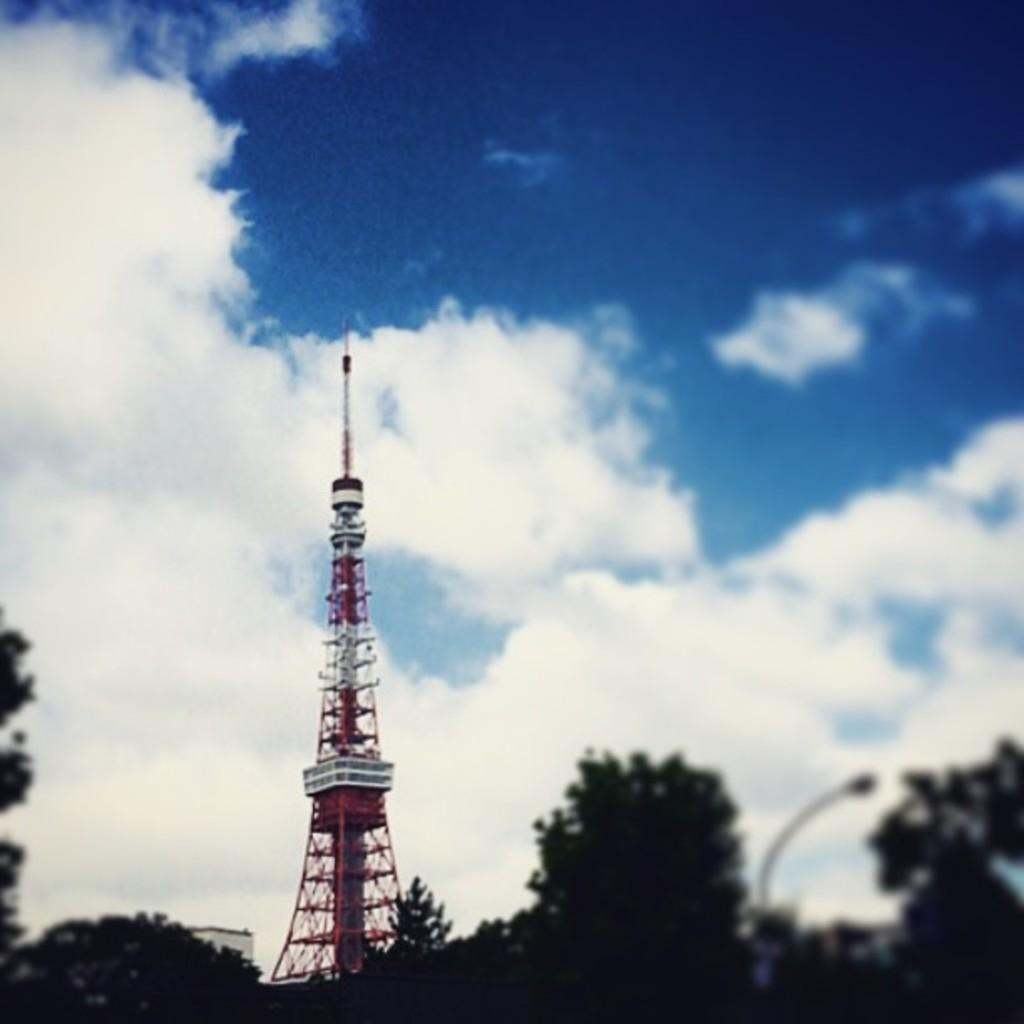What is the main structure in the image? There is a tower in the image. What can be seen in the background of the image? The sky is visible in the background of the image. What is the condition of the sky in the image? Clouds are present in the sky. What direction is the zebra facing in the image? There is no zebra present in the image, so it is not possible to determine the direction it might be facing. 